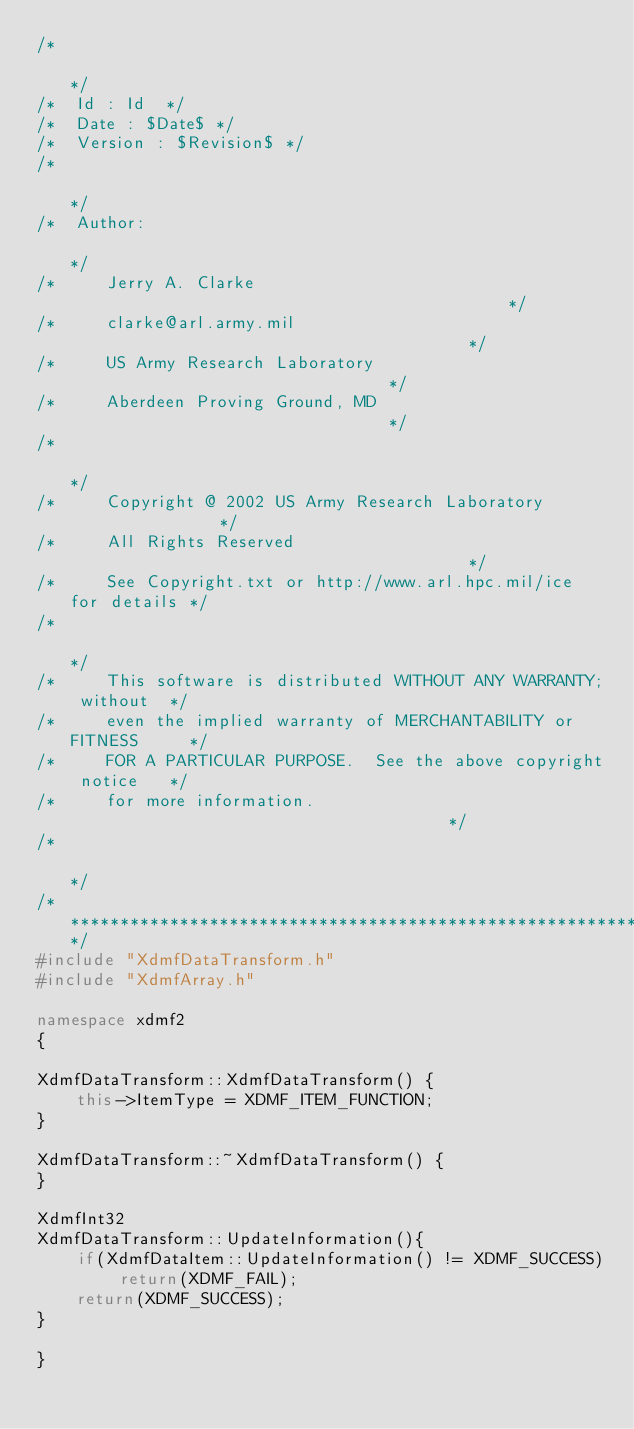<code> <loc_0><loc_0><loc_500><loc_500><_C++_>/*                                                                 */
/*  Id : Id  */
/*  Date : $Date$ */
/*  Version : $Revision$ */
/*                                                                 */
/*  Author:                                                        */
/*     Jerry A. Clarke                                             */
/*     clarke@arl.army.mil                                         */
/*     US Army Research Laboratory                                 */
/*     Aberdeen Proving Ground, MD                                 */
/*                                                                 */
/*     Copyright @ 2002 US Army Research Laboratory                */
/*     All Rights Reserved                                         */
/*     See Copyright.txt or http://www.arl.hpc.mil/ice for details */
/*                                                                 */
/*     This software is distributed WITHOUT ANY WARRANTY; without  */
/*     even the implied warranty of MERCHANTABILITY or FITNESS     */
/*     FOR A PARTICULAR PURPOSE.  See the above copyright notice   */
/*     for more information.                                       */
/*                                                                 */
/*******************************************************************/
#include "XdmfDataTransform.h"
#include "XdmfArray.h"

namespace xdmf2
{

XdmfDataTransform::XdmfDataTransform() {
    this->ItemType = XDMF_ITEM_FUNCTION;
}

XdmfDataTransform::~XdmfDataTransform() {
}

XdmfInt32 
XdmfDataTransform::UpdateInformation(){
    if(XdmfDataItem::UpdateInformation() != XDMF_SUCCESS) return(XDMF_FAIL);
    return(XDMF_SUCCESS);
}

}
</code> 